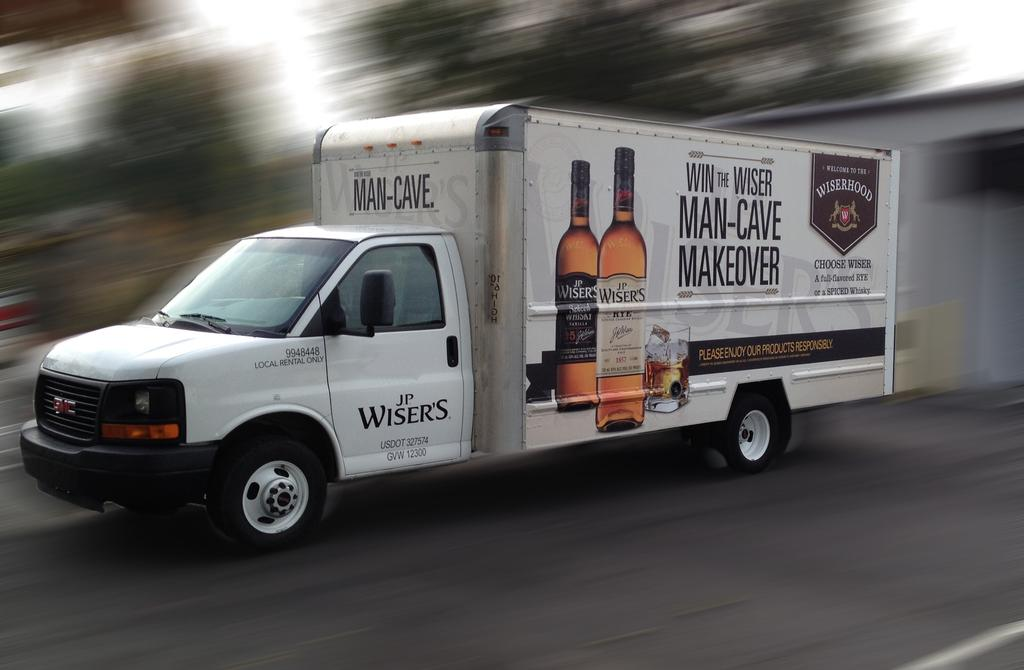<image>
Offer a succinct explanation of the picture presented. A large white van white has the words Man Cave on the front. 